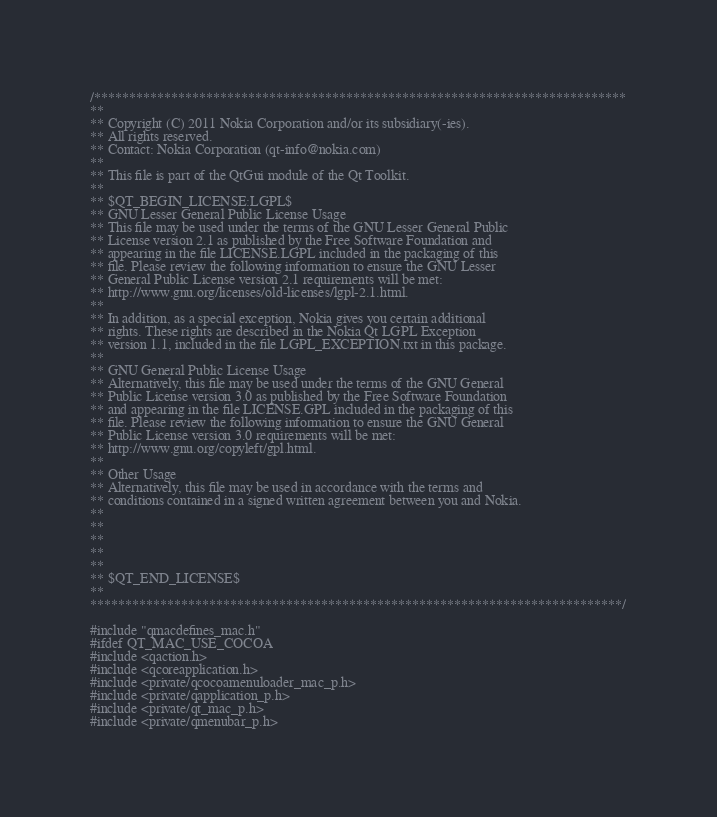Convert code to text. <code><loc_0><loc_0><loc_500><loc_500><_ObjectiveC_>/****************************************************************************
**
** Copyright (C) 2011 Nokia Corporation and/or its subsidiary(-ies).
** All rights reserved.
** Contact: Nokia Corporation (qt-info@nokia.com)
**
** This file is part of the QtGui module of the Qt Toolkit.
**
** $QT_BEGIN_LICENSE:LGPL$
** GNU Lesser General Public License Usage
** This file may be used under the terms of the GNU Lesser General Public
** License version 2.1 as published by the Free Software Foundation and
** appearing in the file LICENSE.LGPL included in the packaging of this
** file. Please review the following information to ensure the GNU Lesser
** General Public License version 2.1 requirements will be met:
** http://www.gnu.org/licenses/old-licenses/lgpl-2.1.html.
**
** In addition, as a special exception, Nokia gives you certain additional
** rights. These rights are described in the Nokia Qt LGPL Exception
** version 1.1, included in the file LGPL_EXCEPTION.txt in this package.
**
** GNU General Public License Usage
** Alternatively, this file may be used under the terms of the GNU General
** Public License version 3.0 as published by the Free Software Foundation
** and appearing in the file LICENSE.GPL included in the packaging of this
** file. Please review the following information to ensure the GNU General
** Public License version 3.0 requirements will be met:
** http://www.gnu.org/copyleft/gpl.html.
**
** Other Usage
** Alternatively, this file may be used in accordance with the terms and
** conditions contained in a signed written agreement between you and Nokia.
**
**
**
**
**
** $QT_END_LICENSE$
**
****************************************************************************/

#include "qmacdefines_mac.h"
#ifdef QT_MAC_USE_COCOA
#include <qaction.h>
#include <qcoreapplication.h>
#include <private/qcocoamenuloader_mac_p.h>
#include <private/qapplication_p.h>
#include <private/qt_mac_p.h>
#include <private/qmenubar_p.h></code> 